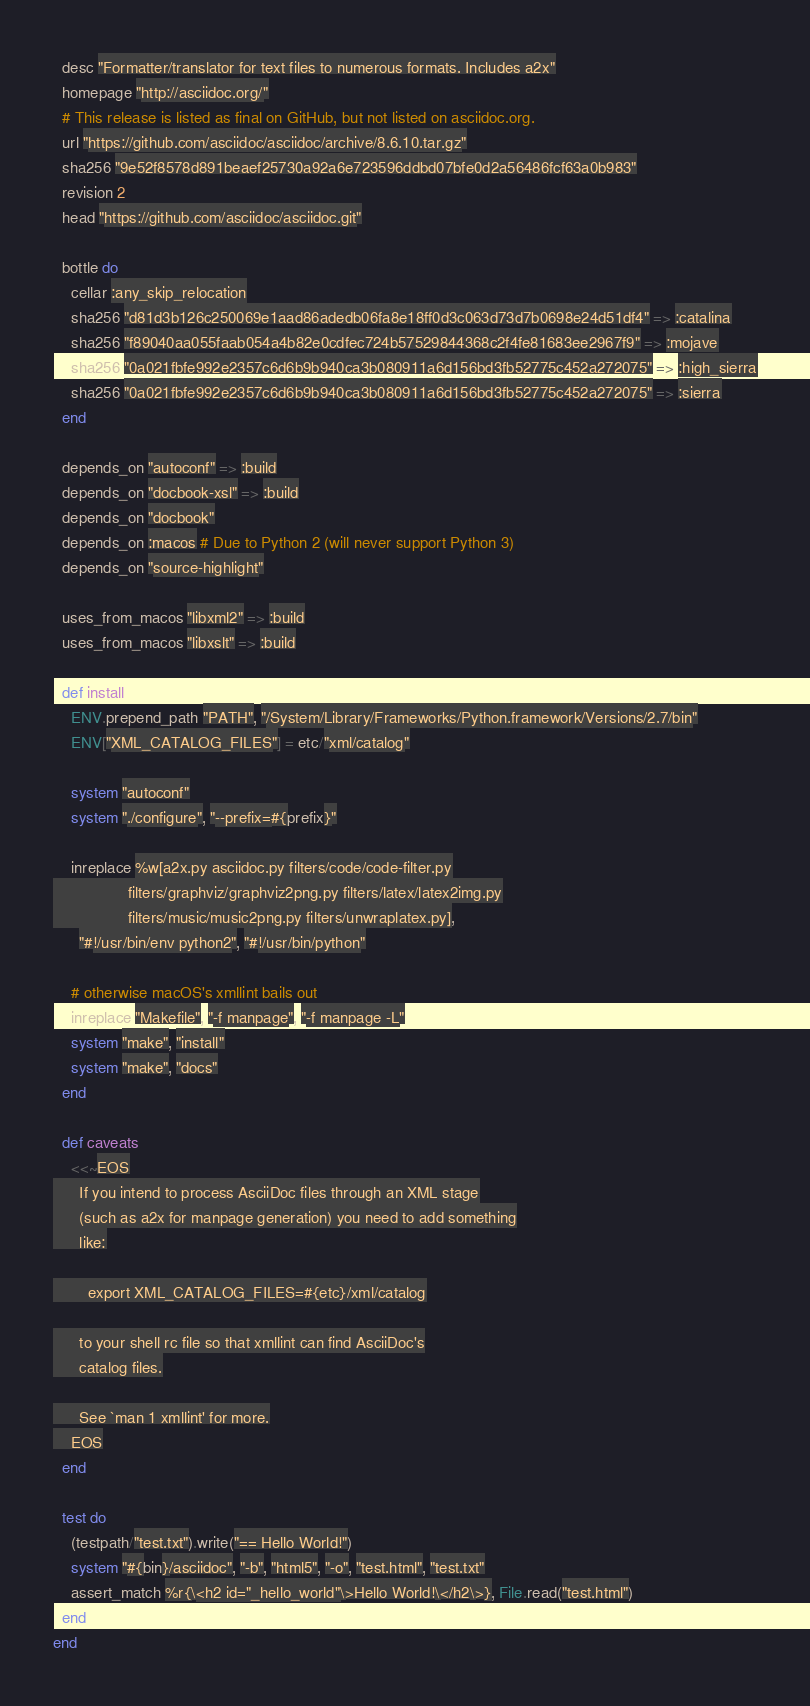<code> <loc_0><loc_0><loc_500><loc_500><_Ruby_>  desc "Formatter/translator for text files to numerous formats. Includes a2x"
  homepage "http://asciidoc.org/"
  # This release is listed as final on GitHub, but not listed on asciidoc.org.
  url "https://github.com/asciidoc/asciidoc/archive/8.6.10.tar.gz"
  sha256 "9e52f8578d891beaef25730a92a6e723596ddbd07bfe0d2a56486fcf63a0b983"
  revision 2
  head "https://github.com/asciidoc/asciidoc.git"

  bottle do
    cellar :any_skip_relocation
    sha256 "d81d3b126c250069e1aad86adedb06fa8e18ff0d3c063d73d7b0698e24d51df4" => :catalina
    sha256 "f89040aa055faab054a4b82e0cdfec724b57529844368c2f4fe81683ee2967f9" => :mojave
    sha256 "0a021fbfe992e2357c6d6b9b940ca3b080911a6d156bd3fb52775c452a272075" => :high_sierra
    sha256 "0a021fbfe992e2357c6d6b9b940ca3b080911a6d156bd3fb52775c452a272075" => :sierra
  end

  depends_on "autoconf" => :build
  depends_on "docbook-xsl" => :build
  depends_on "docbook"
  depends_on :macos # Due to Python 2 (will never support Python 3)
  depends_on "source-highlight"

  uses_from_macos "libxml2" => :build
  uses_from_macos "libxslt" => :build

  def install
    ENV.prepend_path "PATH", "/System/Library/Frameworks/Python.framework/Versions/2.7/bin"
    ENV["XML_CATALOG_FILES"] = etc/"xml/catalog"

    system "autoconf"
    system "./configure", "--prefix=#{prefix}"

    inreplace %w[a2x.py asciidoc.py filters/code/code-filter.py
                 filters/graphviz/graphviz2png.py filters/latex/latex2img.py
                 filters/music/music2png.py filters/unwraplatex.py],
      "#!/usr/bin/env python2", "#!/usr/bin/python"

    # otherwise macOS's xmllint bails out
    inreplace "Makefile", "-f manpage", "-f manpage -L"
    system "make", "install"
    system "make", "docs"
  end

  def caveats
    <<~EOS
      If you intend to process AsciiDoc files through an XML stage
      (such as a2x for manpage generation) you need to add something
      like:

        export XML_CATALOG_FILES=#{etc}/xml/catalog

      to your shell rc file so that xmllint can find AsciiDoc's
      catalog files.

      See `man 1 xmllint' for more.
    EOS
  end

  test do
    (testpath/"test.txt").write("== Hello World!")
    system "#{bin}/asciidoc", "-b", "html5", "-o", "test.html", "test.txt"
    assert_match %r{\<h2 id="_hello_world"\>Hello World!\</h2\>}, File.read("test.html")
  end
end
</code> 